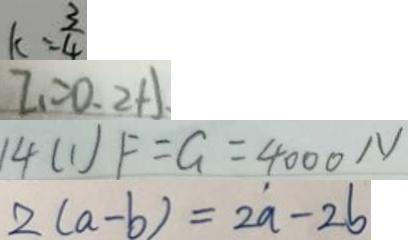<formula> <loc_0><loc_0><loc_500><loc_500>k = \frac { 3 } { 4 } 
 I _ { 1 } = 0 . 2 A 
 1 4 ( 1 ) F = G = 4 0 0 0 N 
 2 ( a - b ) = 2 a - 2 b</formula> 